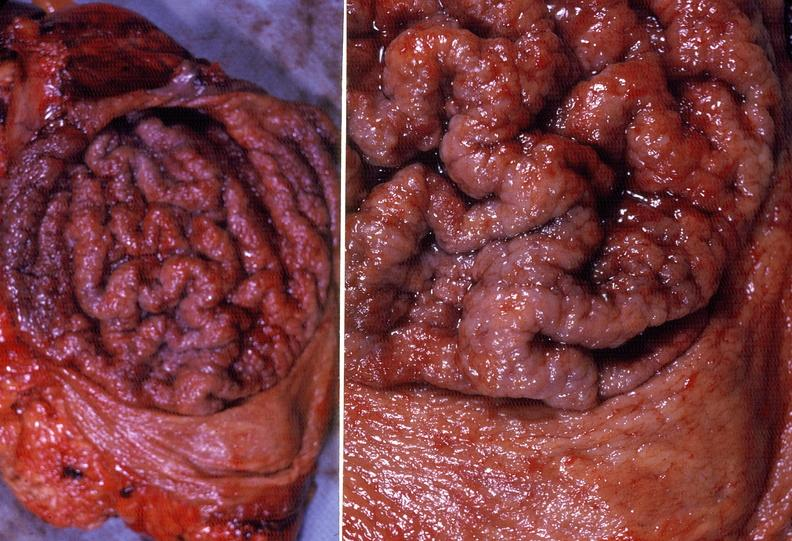does fetus developing very early show stomach, giant rugose hypertrophy?
Answer the question using a single word or phrase. No 